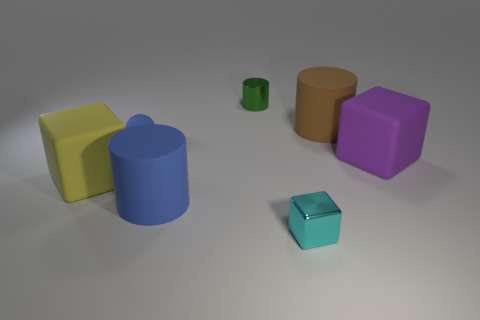Add 1 tiny shiny cylinders. How many objects exist? 8 Subtract all blocks. How many objects are left? 4 Add 7 yellow matte blocks. How many yellow matte blocks exist? 8 Subtract 1 brown cylinders. How many objects are left? 6 Subtract all tiny yellow shiny cylinders. Subtract all blue rubber objects. How many objects are left? 5 Add 4 small green things. How many small green things are left? 5 